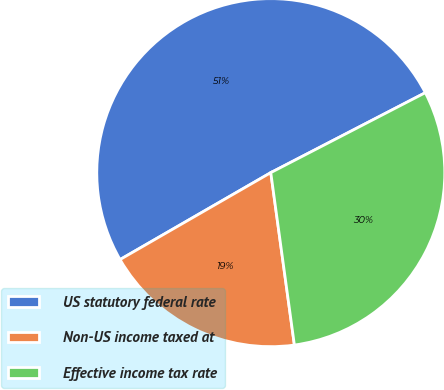Convert chart to OTSL. <chart><loc_0><loc_0><loc_500><loc_500><pie_chart><fcel>US statutory federal rate<fcel>Non-US income taxed at<fcel>Effective income tax rate<nl><fcel>50.72%<fcel>18.84%<fcel>30.43%<nl></chart> 